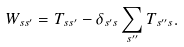<formula> <loc_0><loc_0><loc_500><loc_500>W _ { { s } { s } ^ { \prime } } = T _ { { s } { s } ^ { \prime } } - \delta _ { { s } ^ { \prime } { s } } \sum _ { { s } ^ { \prime \prime } } T _ { { s } ^ { \prime \prime } { s } } .</formula> 